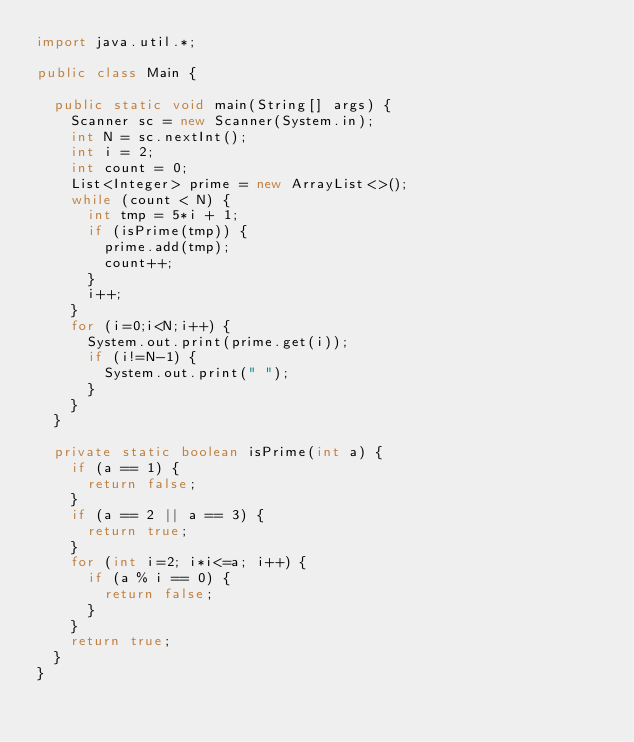<code> <loc_0><loc_0><loc_500><loc_500><_Java_>import java.util.*;

public class Main {

  public static void main(String[] args) {
    Scanner sc = new Scanner(System.in);
    int N = sc.nextInt();
    int i = 2;
    int count = 0;
    List<Integer> prime = new ArrayList<>();
    while (count < N) {
      int tmp = 5*i + 1;
      if (isPrime(tmp)) {
        prime.add(tmp);
        count++;
      }
      i++;
    }
    for (i=0;i<N;i++) {
      System.out.print(prime.get(i));
      if (i!=N-1) {
        System.out.print(" ");
      }
    }
  }

  private static boolean isPrime(int a) {
    if (a == 1) {
      return false;
    }
    if (a == 2 || a == 3) {
      return true;
    }
    for (int i=2; i*i<=a; i++) {
      if (a % i == 0) {
        return false;
      }
    }
    return true;
  }
}
</code> 